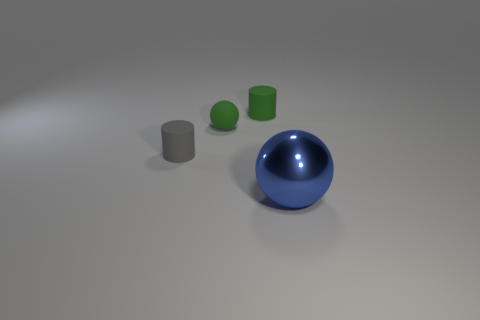Add 2 matte spheres. How many objects exist? 6 Subtract all red spheres. How many brown cylinders are left? 0 Subtract all green matte balls. Subtract all tiny cylinders. How many objects are left? 1 Add 4 small green rubber things. How many small green rubber things are left? 6 Add 3 large gray metal things. How many large gray metal things exist? 3 Subtract 0 red cylinders. How many objects are left? 4 Subtract all green balls. Subtract all green cylinders. How many balls are left? 1 